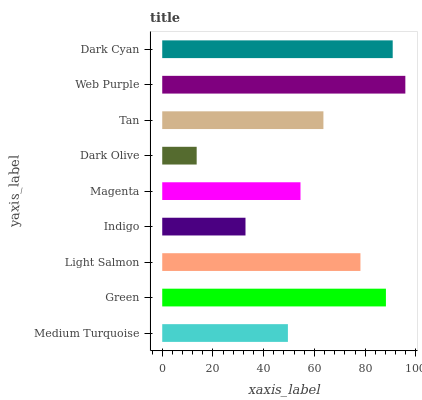Is Dark Olive the minimum?
Answer yes or no. Yes. Is Web Purple the maximum?
Answer yes or no. Yes. Is Green the minimum?
Answer yes or no. No. Is Green the maximum?
Answer yes or no. No. Is Green greater than Medium Turquoise?
Answer yes or no. Yes. Is Medium Turquoise less than Green?
Answer yes or no. Yes. Is Medium Turquoise greater than Green?
Answer yes or no. No. Is Green less than Medium Turquoise?
Answer yes or no. No. Is Tan the high median?
Answer yes or no. Yes. Is Tan the low median?
Answer yes or no. Yes. Is Magenta the high median?
Answer yes or no. No. Is Green the low median?
Answer yes or no. No. 